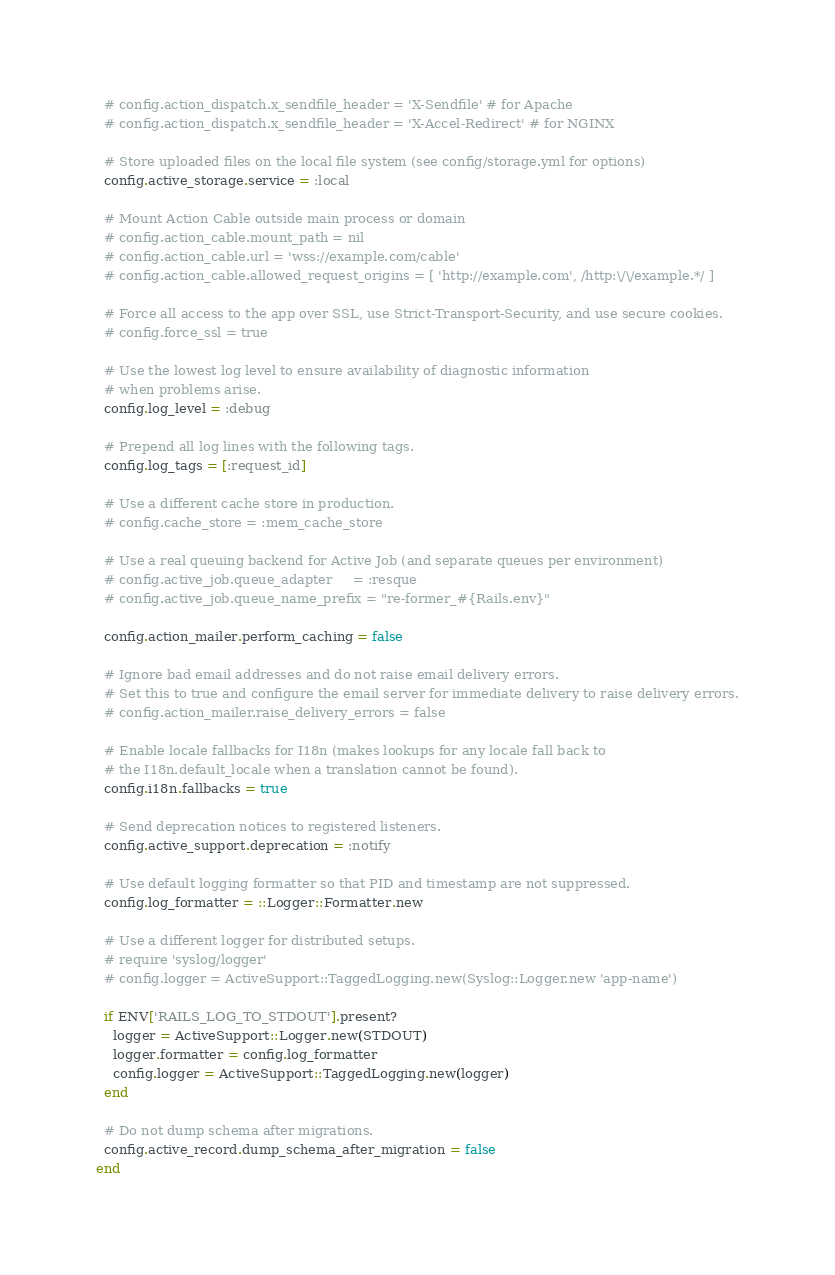<code> <loc_0><loc_0><loc_500><loc_500><_Ruby_>  # config.action_dispatch.x_sendfile_header = 'X-Sendfile' # for Apache
  # config.action_dispatch.x_sendfile_header = 'X-Accel-Redirect' # for NGINX

  # Store uploaded files on the local file system (see config/storage.yml for options)
  config.active_storage.service = :local

  # Mount Action Cable outside main process or domain
  # config.action_cable.mount_path = nil
  # config.action_cable.url = 'wss://example.com/cable'
  # config.action_cable.allowed_request_origins = [ 'http://example.com', /http:\/\/example.*/ ]

  # Force all access to the app over SSL, use Strict-Transport-Security, and use secure cookies.
  # config.force_ssl = true

  # Use the lowest log level to ensure availability of diagnostic information
  # when problems arise.
  config.log_level = :debug

  # Prepend all log lines with the following tags.
  config.log_tags = [:request_id]

  # Use a different cache store in production.
  # config.cache_store = :mem_cache_store

  # Use a real queuing backend for Active Job (and separate queues per environment)
  # config.active_job.queue_adapter     = :resque
  # config.active_job.queue_name_prefix = "re-former_#{Rails.env}"

  config.action_mailer.perform_caching = false

  # Ignore bad email addresses and do not raise email delivery errors.
  # Set this to true and configure the email server for immediate delivery to raise delivery errors.
  # config.action_mailer.raise_delivery_errors = false

  # Enable locale fallbacks for I18n (makes lookups for any locale fall back to
  # the I18n.default_locale when a translation cannot be found).
  config.i18n.fallbacks = true

  # Send deprecation notices to registered listeners.
  config.active_support.deprecation = :notify

  # Use default logging formatter so that PID and timestamp are not suppressed.
  config.log_formatter = ::Logger::Formatter.new

  # Use a different logger for distributed setups.
  # require 'syslog/logger'
  # config.logger = ActiveSupport::TaggedLogging.new(Syslog::Logger.new 'app-name')

  if ENV['RAILS_LOG_TO_STDOUT'].present?
    logger = ActiveSupport::Logger.new(STDOUT)
    logger.formatter = config.log_formatter
    config.logger = ActiveSupport::TaggedLogging.new(logger)
  end

  # Do not dump schema after migrations.
  config.active_record.dump_schema_after_migration = false
end
</code> 